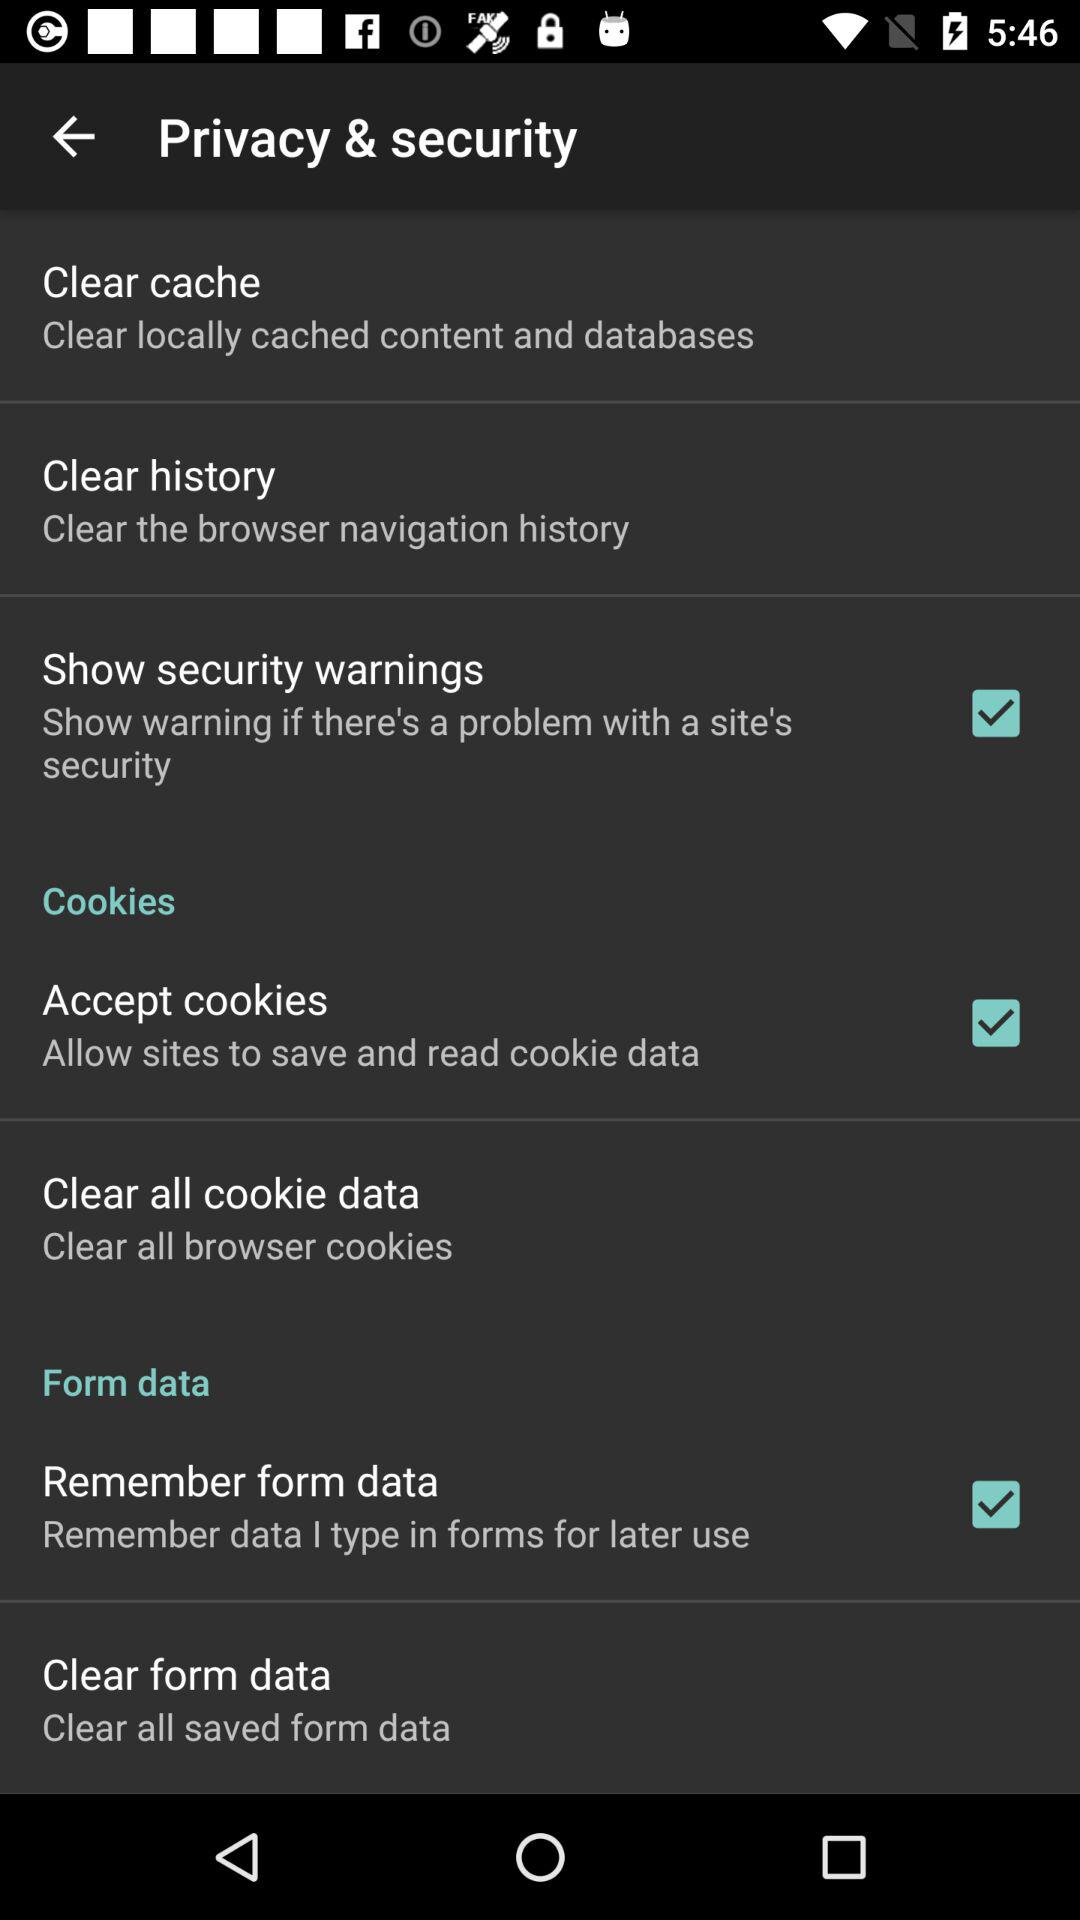What is the status of "Show security warnings"? The status of "Show security warnings" is "on". 